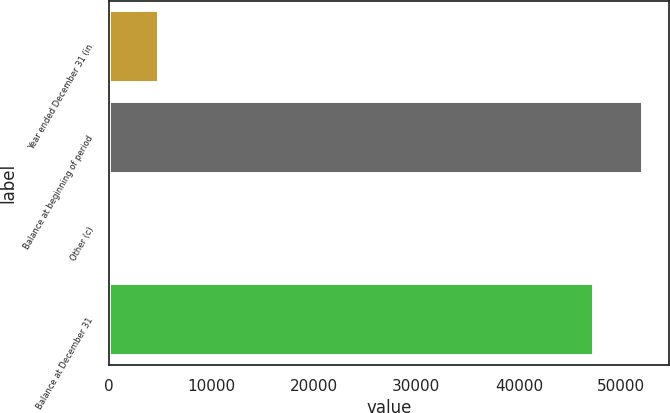Convert chart. <chart><loc_0><loc_0><loc_500><loc_500><bar_chart><fcel>Year ended December 31 (in<fcel>Balance at beginning of period<fcel>Other (c)<fcel>Balance at December 31<nl><fcel>4935.7<fcel>52070.7<fcel>190<fcel>47325<nl></chart> 